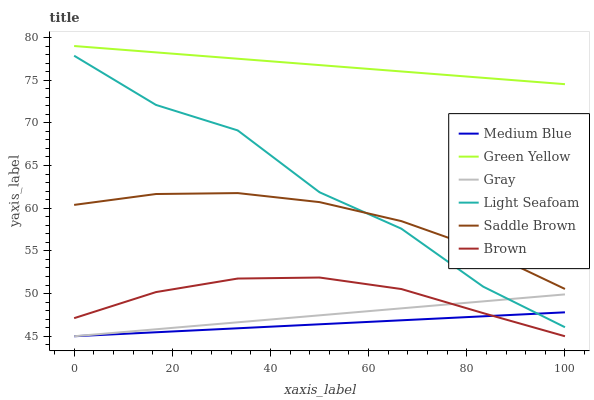Does Medium Blue have the minimum area under the curve?
Answer yes or no. Yes. Does Green Yellow have the maximum area under the curve?
Answer yes or no. Yes. Does Light Seafoam have the minimum area under the curve?
Answer yes or no. No. Does Light Seafoam have the maximum area under the curve?
Answer yes or no. No. Is Gray the smoothest?
Answer yes or no. Yes. Is Light Seafoam the roughest?
Answer yes or no. Yes. Is Brown the smoothest?
Answer yes or no. No. Is Brown the roughest?
Answer yes or no. No. Does Light Seafoam have the lowest value?
Answer yes or no. No. Does Green Yellow have the highest value?
Answer yes or no. Yes. Does Light Seafoam have the highest value?
Answer yes or no. No. Is Brown less than Light Seafoam?
Answer yes or no. Yes. Is Saddle Brown greater than Brown?
Answer yes or no. Yes. Does Brown intersect Light Seafoam?
Answer yes or no. No. 